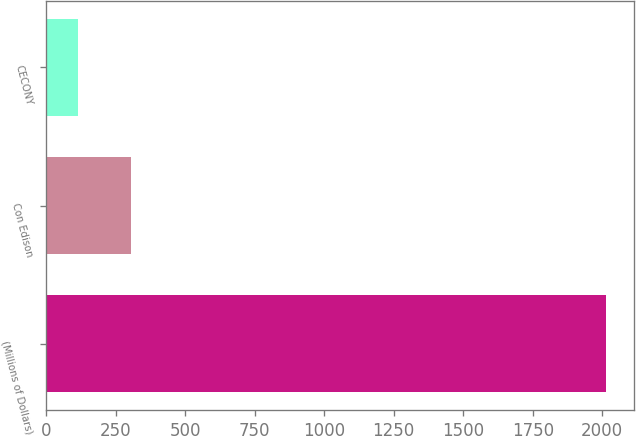Convert chart to OTSL. <chart><loc_0><loc_0><loc_500><loc_500><bar_chart><fcel>(Millions of Dollars)<fcel>Con Edison<fcel>CECONY<nl><fcel>2013<fcel>304.8<fcel>115<nl></chart> 